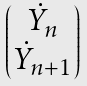<formula> <loc_0><loc_0><loc_500><loc_500>\begin{pmatrix} \dot { Y } _ { n } \\ \dot { Y } _ { n + 1 } \end{pmatrix}</formula> 